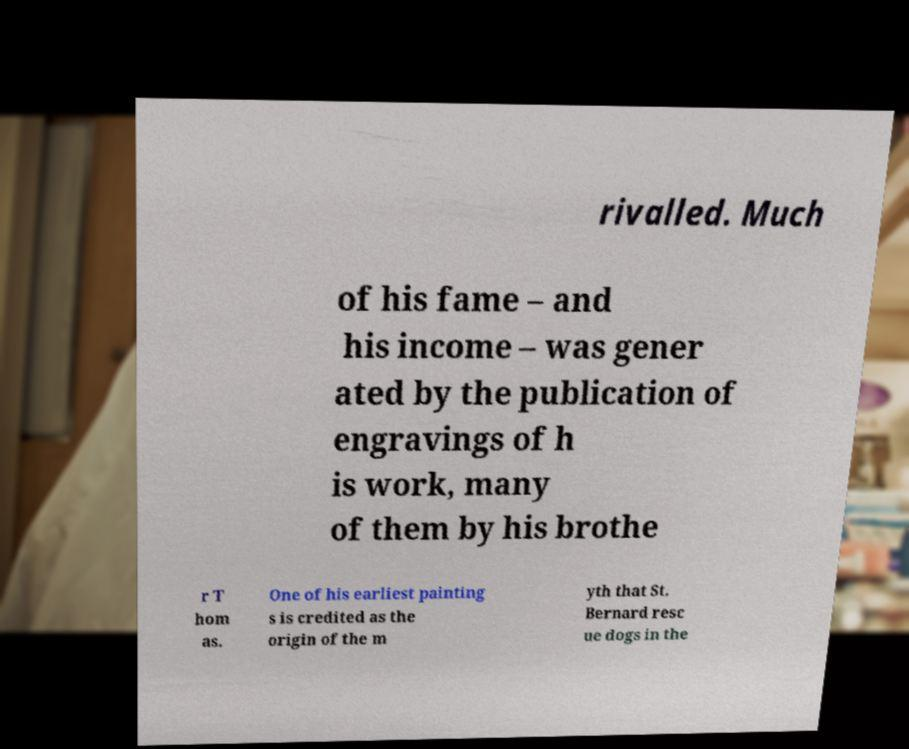I need the written content from this picture converted into text. Can you do that? rivalled. Much of his fame – and his income – was gener ated by the publication of engravings of h is work, many of them by his brothe r T hom as. One of his earliest painting s is credited as the origin of the m yth that St. Bernard resc ue dogs in the 